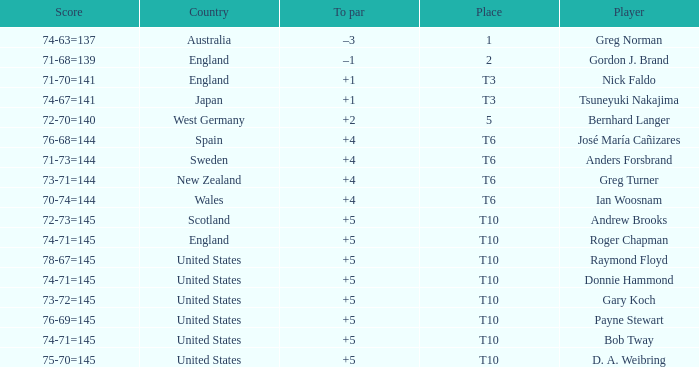What was Anders Forsbrand's score when the TO par is +4? 71-73=144. 